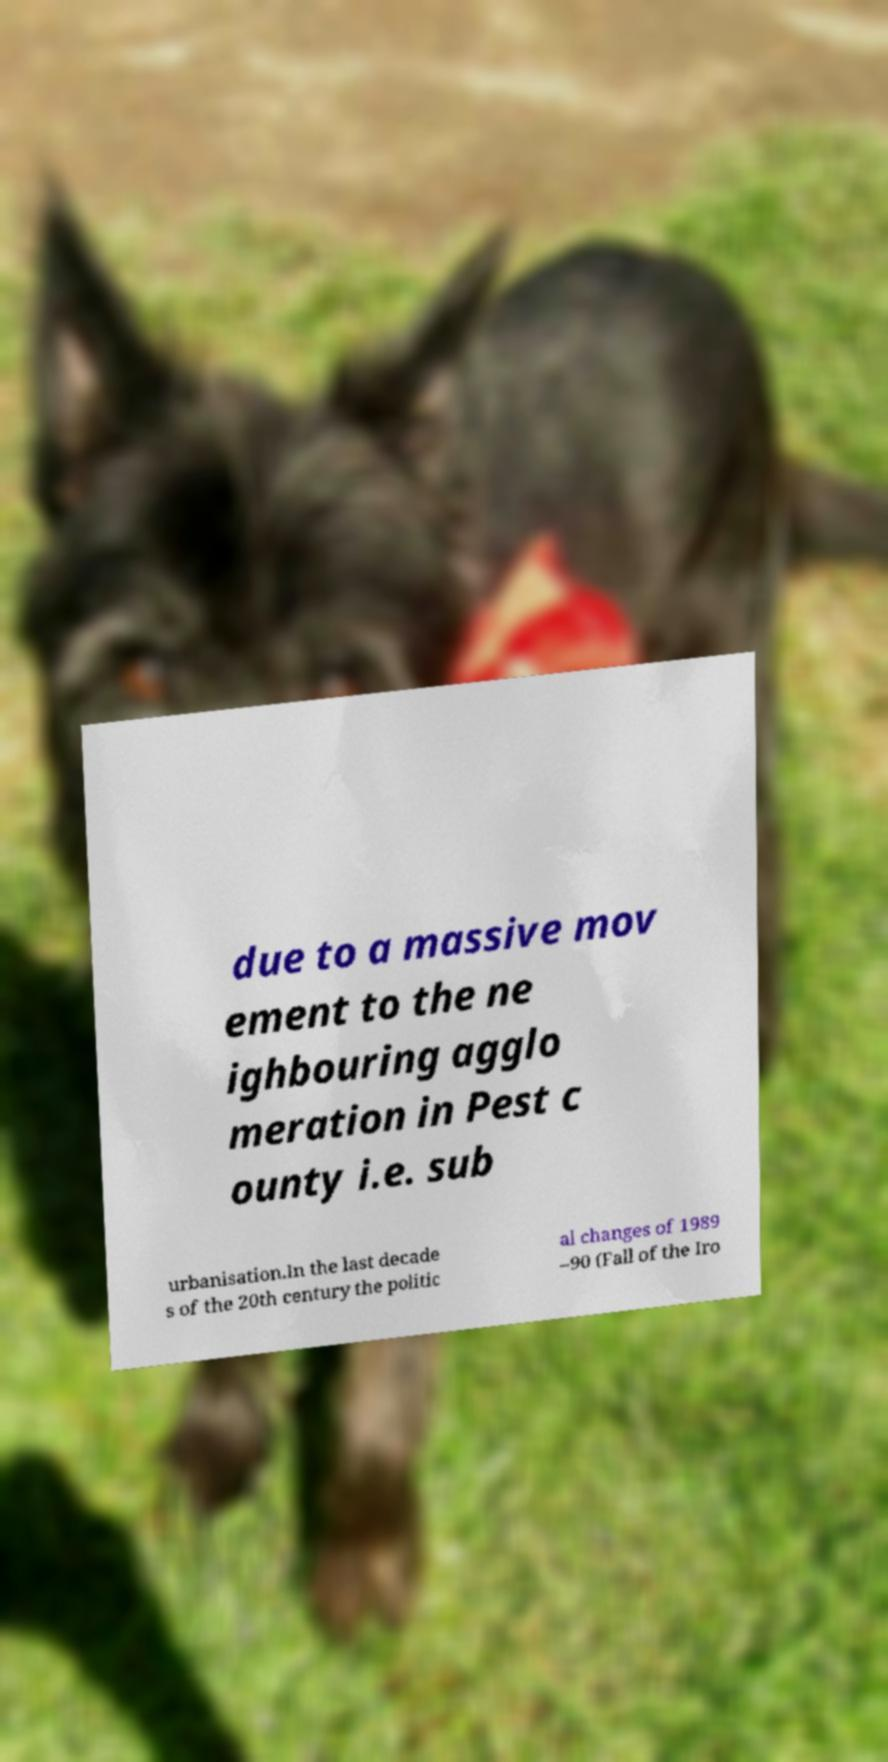I need the written content from this picture converted into text. Can you do that? due to a massive mov ement to the ne ighbouring agglo meration in Pest c ounty i.e. sub urbanisation.In the last decade s of the 20th century the politic al changes of 1989 –90 (Fall of the Iro 